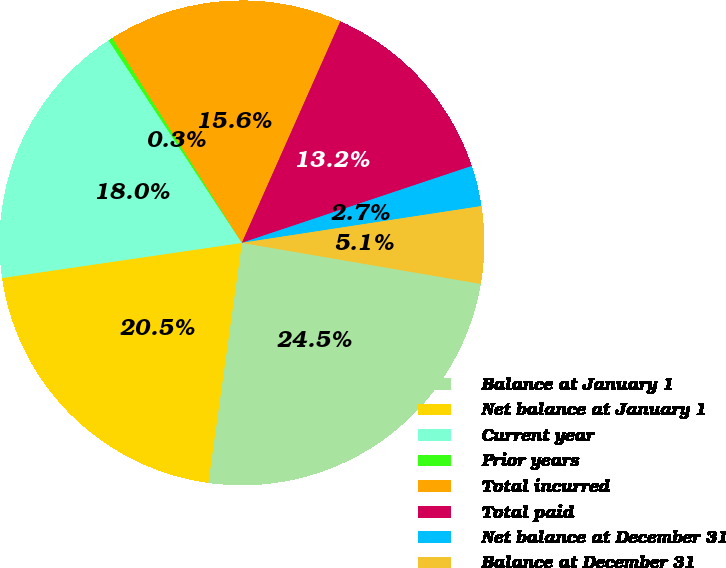<chart> <loc_0><loc_0><loc_500><loc_500><pie_chart><fcel>Balance at January 1<fcel>Net balance at January 1<fcel>Current year<fcel>Prior years<fcel>Total incurred<fcel>Total paid<fcel>Net balance at December 31<fcel>Balance at December 31<nl><fcel>24.51%<fcel>20.47%<fcel>18.05%<fcel>0.29%<fcel>15.63%<fcel>13.21%<fcel>2.71%<fcel>5.13%<nl></chart> 